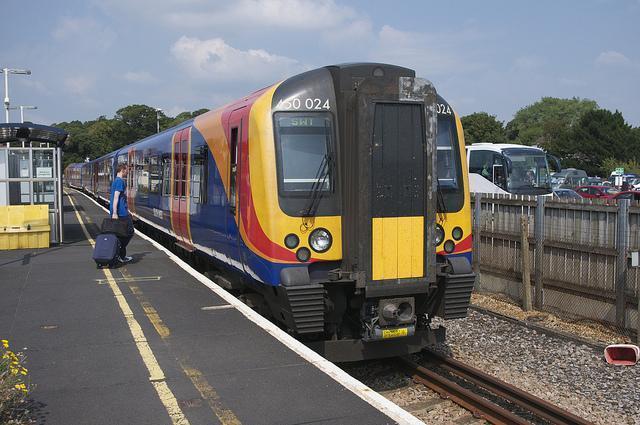How many people are waiting to get on the train?
Give a very brief answer. 1. 